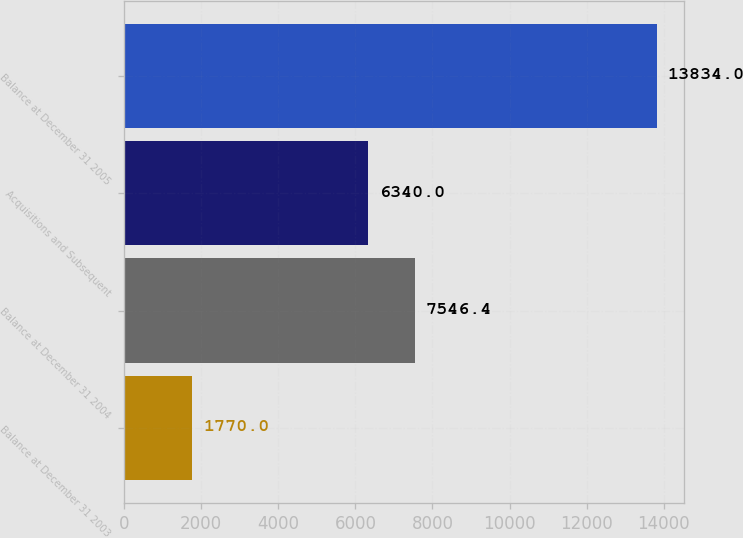<chart> <loc_0><loc_0><loc_500><loc_500><bar_chart><fcel>Balance at December 31 2003<fcel>Balance at December 31 2004<fcel>Acquisitions and Subsequent<fcel>Balance at December 31 2005<nl><fcel>1770<fcel>7546.4<fcel>6340<fcel>13834<nl></chart> 